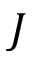<formula> <loc_0><loc_0><loc_500><loc_500>J</formula> 